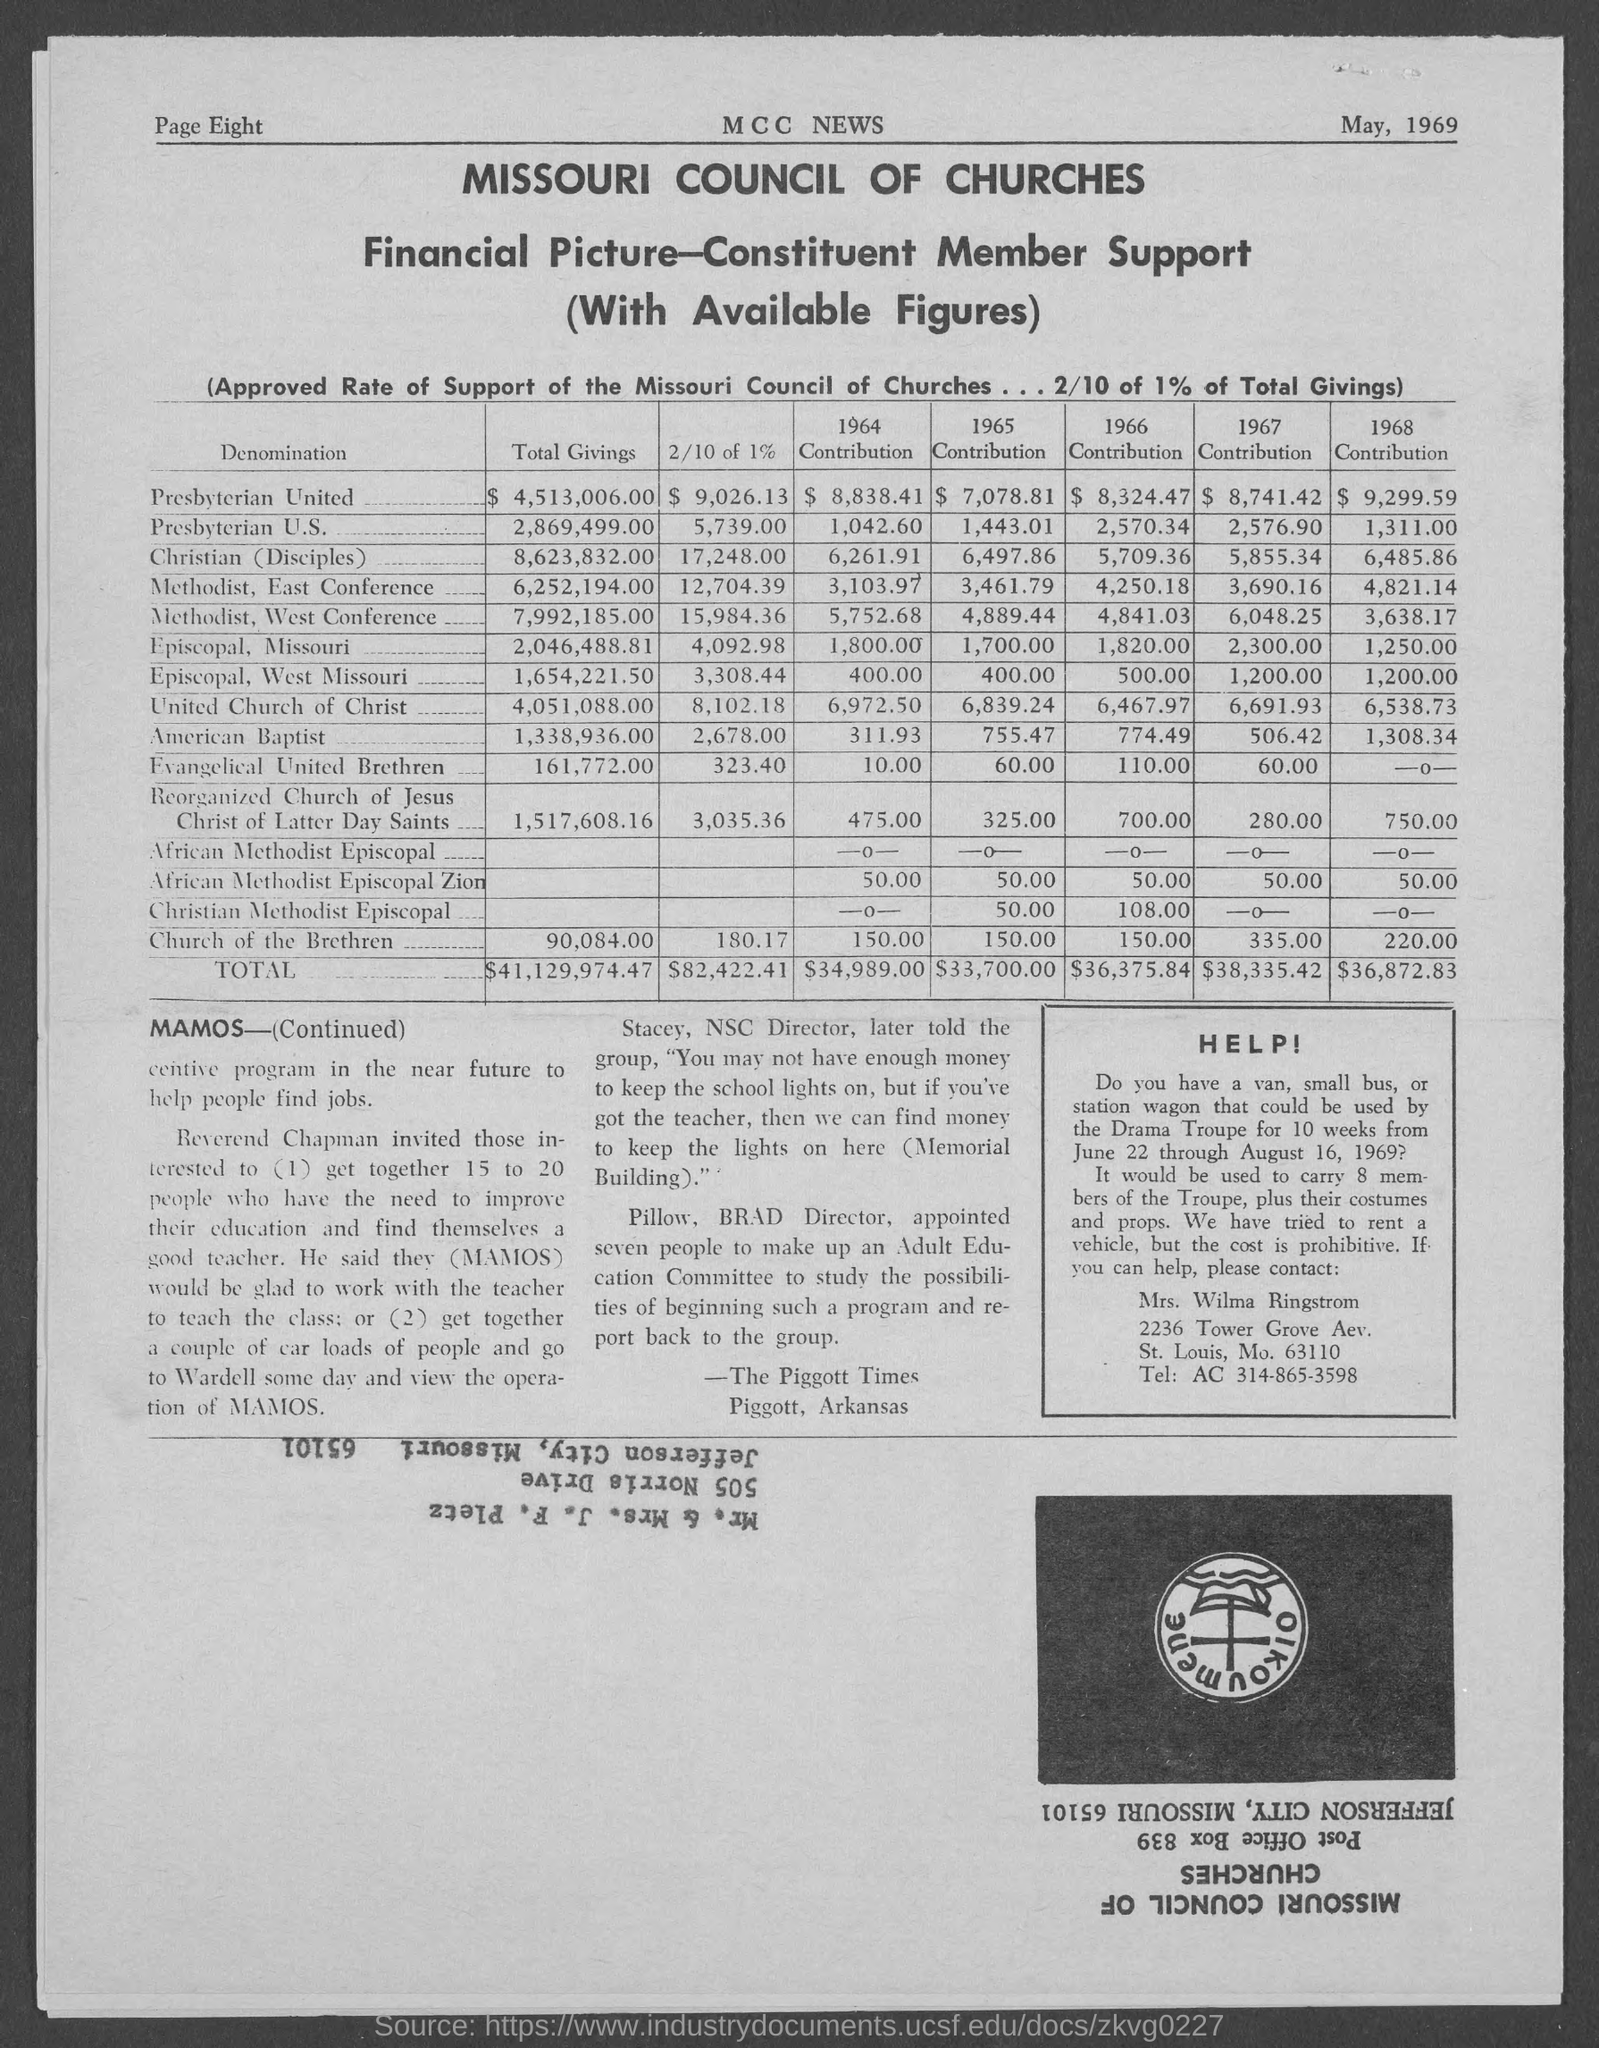Draw attention to some important aspects in this diagram. The title of the document is "What is the Title of the document? The total giving for Presbyterian U.S. is 2,869,499.00. The total giving for Methodist, East Conference was 6,252,194.00. The date on the document is May 1969. The total giving for American Baptist is 1,338,936.00. 